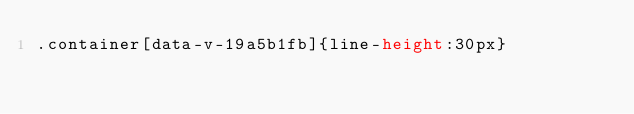Convert code to text. <code><loc_0><loc_0><loc_500><loc_500><_CSS_>.container[data-v-19a5b1fb]{line-height:30px}</code> 